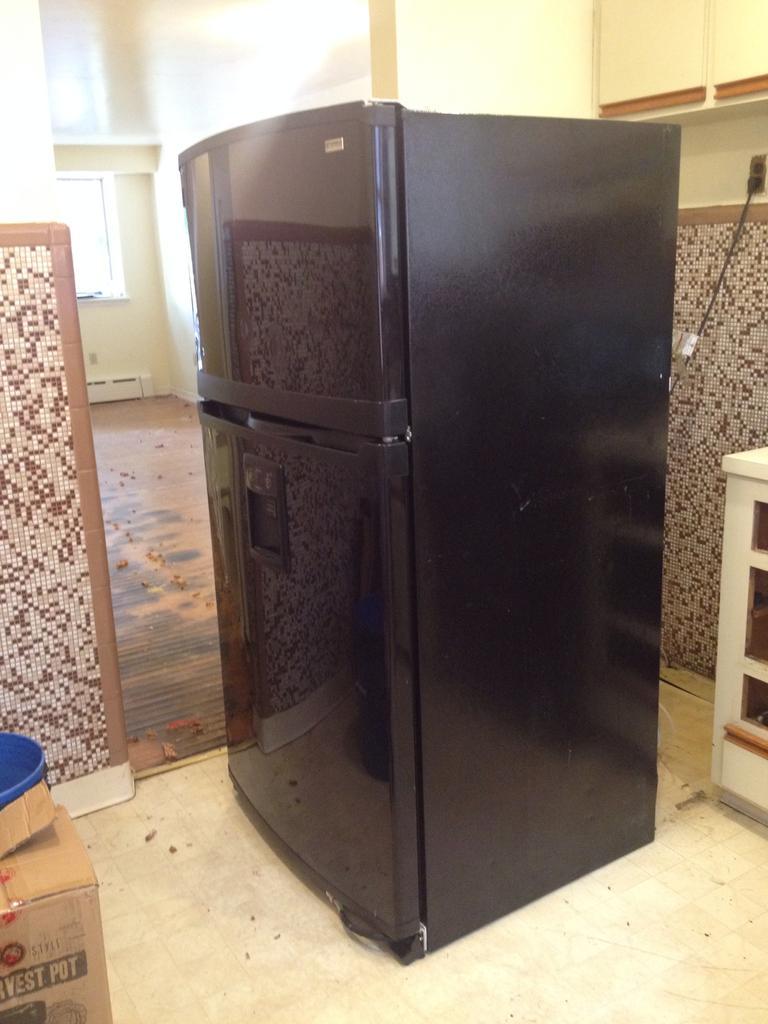Please provide a concise description of this image. The picture is taken in a house. In the center of the picture there is a refrigerator. On the right there is a box. On the left there is a desk. At the top there is closet and a wall. In the center of the background there is a window and a wall. 